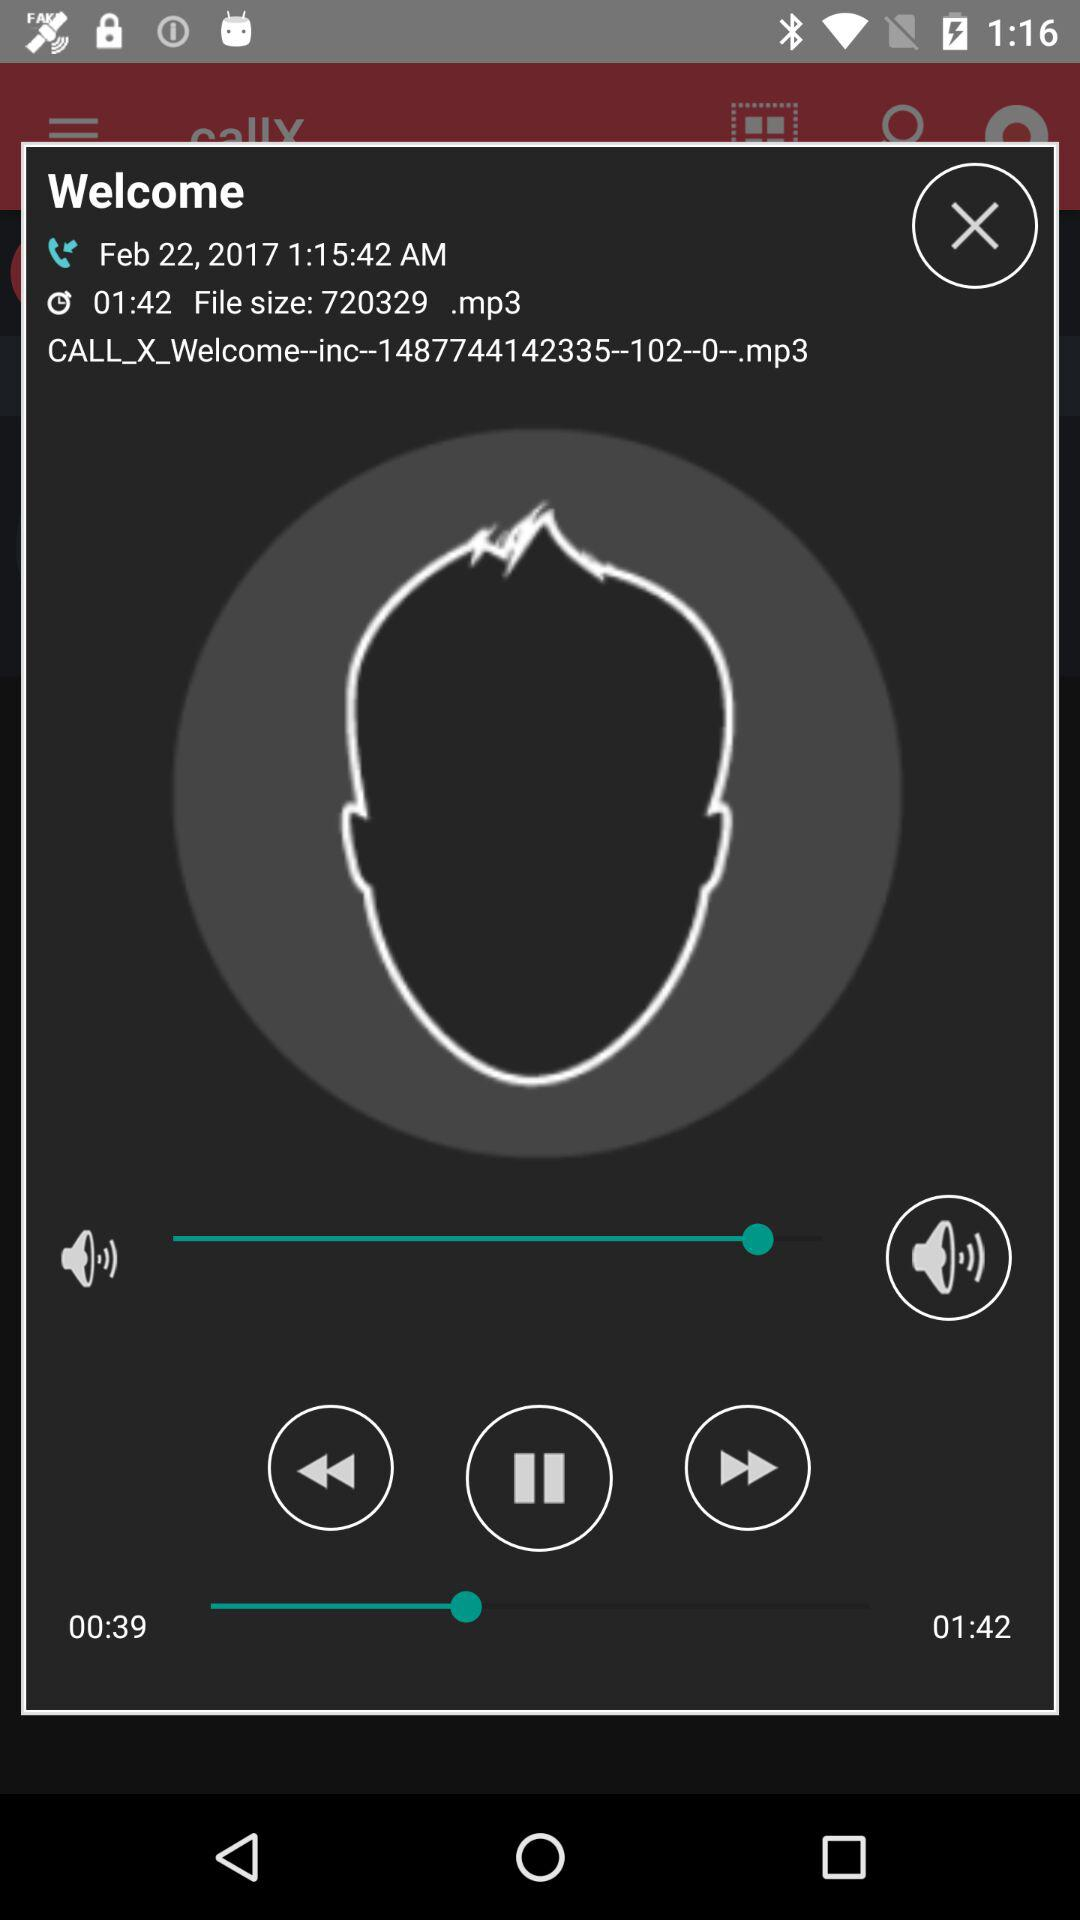What is the duration of the record? The duration of the record is 01:42. 